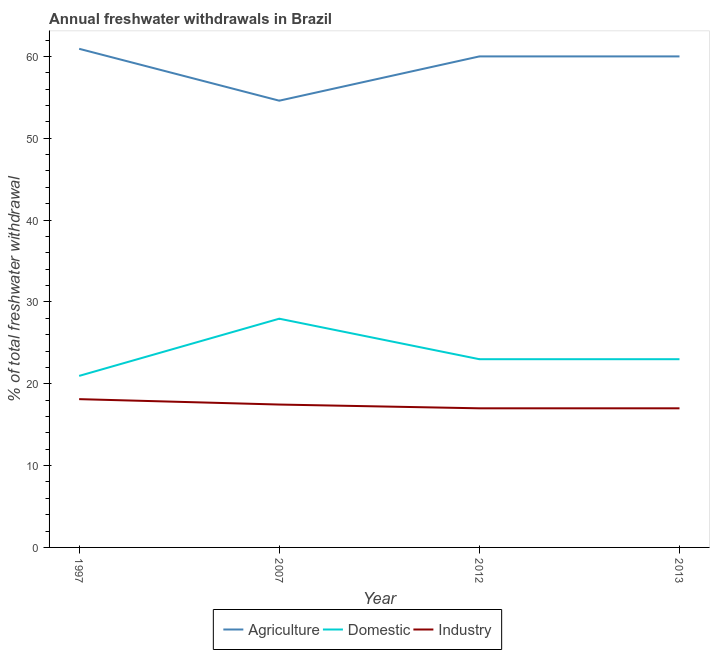Is the number of lines equal to the number of legend labels?
Ensure brevity in your answer.  Yes. What is the percentage of freshwater withdrawal for industry in 2012?
Make the answer very short. 17. Across all years, what is the maximum percentage of freshwater withdrawal for agriculture?
Offer a very short reply. 60.93. In which year was the percentage of freshwater withdrawal for agriculture minimum?
Keep it short and to the point. 2007. What is the total percentage of freshwater withdrawal for industry in the graph?
Offer a terse response. 69.58. What is the difference between the percentage of freshwater withdrawal for industry in 1997 and that in 2007?
Offer a very short reply. 0.66. What is the difference between the percentage of freshwater withdrawal for domestic purposes in 2013 and the percentage of freshwater withdrawal for agriculture in 2007?
Your answer should be very brief. -31.59. What is the average percentage of freshwater withdrawal for domestic purposes per year?
Provide a short and direct response. 23.73. In the year 2013, what is the difference between the percentage of freshwater withdrawal for domestic purposes and percentage of freshwater withdrawal for agriculture?
Offer a terse response. -37. In how many years, is the percentage of freshwater withdrawal for domestic purposes greater than 58 %?
Ensure brevity in your answer.  0. What is the ratio of the percentage of freshwater withdrawal for agriculture in 1997 to that in 2007?
Your answer should be compact. 1.12. What is the difference between the highest and the second highest percentage of freshwater withdrawal for agriculture?
Offer a terse response. 0.93. What is the difference between the highest and the lowest percentage of freshwater withdrawal for domestic purposes?
Your answer should be very brief. 6.99. In how many years, is the percentage of freshwater withdrawal for industry greater than the average percentage of freshwater withdrawal for industry taken over all years?
Your answer should be very brief. 2. Is it the case that in every year, the sum of the percentage of freshwater withdrawal for agriculture and percentage of freshwater withdrawal for domestic purposes is greater than the percentage of freshwater withdrawal for industry?
Your answer should be compact. Yes. Is the percentage of freshwater withdrawal for agriculture strictly greater than the percentage of freshwater withdrawal for industry over the years?
Give a very brief answer. Yes. Is the percentage of freshwater withdrawal for agriculture strictly less than the percentage of freshwater withdrawal for domestic purposes over the years?
Provide a succinct answer. No. How many lines are there?
Ensure brevity in your answer.  3. How many years are there in the graph?
Your response must be concise. 4. What is the difference between two consecutive major ticks on the Y-axis?
Keep it short and to the point. 10. Are the values on the major ticks of Y-axis written in scientific E-notation?
Your answer should be compact. No. How are the legend labels stacked?
Your answer should be very brief. Horizontal. What is the title of the graph?
Offer a terse response. Annual freshwater withdrawals in Brazil. What is the label or title of the X-axis?
Your answer should be compact. Year. What is the label or title of the Y-axis?
Your answer should be very brief. % of total freshwater withdrawal. What is the % of total freshwater withdrawal in Agriculture in 1997?
Give a very brief answer. 60.93. What is the % of total freshwater withdrawal of Domestic in 1997?
Provide a succinct answer. 20.96. What is the % of total freshwater withdrawal in Industry in 1997?
Your answer should be very brief. 18.12. What is the % of total freshwater withdrawal of Agriculture in 2007?
Give a very brief answer. 54.59. What is the % of total freshwater withdrawal in Domestic in 2007?
Offer a terse response. 27.95. What is the % of total freshwater withdrawal in Industry in 2007?
Keep it short and to the point. 17.46. What is the % of total freshwater withdrawal in Domestic in 2012?
Your answer should be compact. 23. What is the % of total freshwater withdrawal of Industry in 2012?
Provide a succinct answer. 17. What is the % of total freshwater withdrawal of Agriculture in 2013?
Provide a succinct answer. 60. What is the % of total freshwater withdrawal in Industry in 2013?
Offer a very short reply. 17. Across all years, what is the maximum % of total freshwater withdrawal of Agriculture?
Your answer should be very brief. 60.93. Across all years, what is the maximum % of total freshwater withdrawal in Domestic?
Offer a very short reply. 27.95. Across all years, what is the maximum % of total freshwater withdrawal of Industry?
Provide a succinct answer. 18.12. Across all years, what is the minimum % of total freshwater withdrawal in Agriculture?
Make the answer very short. 54.59. Across all years, what is the minimum % of total freshwater withdrawal in Domestic?
Keep it short and to the point. 20.96. What is the total % of total freshwater withdrawal of Agriculture in the graph?
Your answer should be very brief. 235.52. What is the total % of total freshwater withdrawal in Domestic in the graph?
Give a very brief answer. 94.91. What is the total % of total freshwater withdrawal of Industry in the graph?
Your response must be concise. 69.58. What is the difference between the % of total freshwater withdrawal of Agriculture in 1997 and that in 2007?
Provide a short and direct response. 6.34. What is the difference between the % of total freshwater withdrawal of Domestic in 1997 and that in 2007?
Offer a very short reply. -6.99. What is the difference between the % of total freshwater withdrawal of Industry in 1997 and that in 2007?
Offer a very short reply. 0.66. What is the difference between the % of total freshwater withdrawal of Agriculture in 1997 and that in 2012?
Make the answer very short. 0.93. What is the difference between the % of total freshwater withdrawal in Domestic in 1997 and that in 2012?
Ensure brevity in your answer.  -2.04. What is the difference between the % of total freshwater withdrawal of Industry in 1997 and that in 2012?
Offer a terse response. 1.12. What is the difference between the % of total freshwater withdrawal in Agriculture in 1997 and that in 2013?
Offer a terse response. 0.93. What is the difference between the % of total freshwater withdrawal of Domestic in 1997 and that in 2013?
Provide a succinct answer. -2.04. What is the difference between the % of total freshwater withdrawal in Industry in 1997 and that in 2013?
Ensure brevity in your answer.  1.12. What is the difference between the % of total freshwater withdrawal in Agriculture in 2007 and that in 2012?
Your response must be concise. -5.41. What is the difference between the % of total freshwater withdrawal of Domestic in 2007 and that in 2012?
Your answer should be very brief. 4.95. What is the difference between the % of total freshwater withdrawal of Industry in 2007 and that in 2012?
Provide a succinct answer. 0.46. What is the difference between the % of total freshwater withdrawal of Agriculture in 2007 and that in 2013?
Make the answer very short. -5.41. What is the difference between the % of total freshwater withdrawal of Domestic in 2007 and that in 2013?
Offer a terse response. 4.95. What is the difference between the % of total freshwater withdrawal in Industry in 2007 and that in 2013?
Give a very brief answer. 0.46. What is the difference between the % of total freshwater withdrawal of Domestic in 2012 and that in 2013?
Your answer should be very brief. 0. What is the difference between the % of total freshwater withdrawal in Agriculture in 1997 and the % of total freshwater withdrawal in Domestic in 2007?
Ensure brevity in your answer.  32.98. What is the difference between the % of total freshwater withdrawal in Agriculture in 1997 and the % of total freshwater withdrawal in Industry in 2007?
Offer a very short reply. 43.47. What is the difference between the % of total freshwater withdrawal of Domestic in 1997 and the % of total freshwater withdrawal of Industry in 2007?
Provide a succinct answer. 3.5. What is the difference between the % of total freshwater withdrawal of Agriculture in 1997 and the % of total freshwater withdrawal of Domestic in 2012?
Give a very brief answer. 37.93. What is the difference between the % of total freshwater withdrawal in Agriculture in 1997 and the % of total freshwater withdrawal in Industry in 2012?
Provide a short and direct response. 43.93. What is the difference between the % of total freshwater withdrawal in Domestic in 1997 and the % of total freshwater withdrawal in Industry in 2012?
Give a very brief answer. 3.96. What is the difference between the % of total freshwater withdrawal of Agriculture in 1997 and the % of total freshwater withdrawal of Domestic in 2013?
Make the answer very short. 37.93. What is the difference between the % of total freshwater withdrawal in Agriculture in 1997 and the % of total freshwater withdrawal in Industry in 2013?
Offer a very short reply. 43.93. What is the difference between the % of total freshwater withdrawal in Domestic in 1997 and the % of total freshwater withdrawal in Industry in 2013?
Provide a succinct answer. 3.96. What is the difference between the % of total freshwater withdrawal in Agriculture in 2007 and the % of total freshwater withdrawal in Domestic in 2012?
Make the answer very short. 31.59. What is the difference between the % of total freshwater withdrawal of Agriculture in 2007 and the % of total freshwater withdrawal of Industry in 2012?
Your answer should be compact. 37.59. What is the difference between the % of total freshwater withdrawal in Domestic in 2007 and the % of total freshwater withdrawal in Industry in 2012?
Ensure brevity in your answer.  10.95. What is the difference between the % of total freshwater withdrawal of Agriculture in 2007 and the % of total freshwater withdrawal of Domestic in 2013?
Your response must be concise. 31.59. What is the difference between the % of total freshwater withdrawal of Agriculture in 2007 and the % of total freshwater withdrawal of Industry in 2013?
Ensure brevity in your answer.  37.59. What is the difference between the % of total freshwater withdrawal in Domestic in 2007 and the % of total freshwater withdrawal in Industry in 2013?
Make the answer very short. 10.95. What is the average % of total freshwater withdrawal in Agriculture per year?
Provide a short and direct response. 58.88. What is the average % of total freshwater withdrawal in Domestic per year?
Your response must be concise. 23.73. What is the average % of total freshwater withdrawal in Industry per year?
Offer a terse response. 17.39. In the year 1997, what is the difference between the % of total freshwater withdrawal of Agriculture and % of total freshwater withdrawal of Domestic?
Keep it short and to the point. 39.97. In the year 1997, what is the difference between the % of total freshwater withdrawal of Agriculture and % of total freshwater withdrawal of Industry?
Provide a short and direct response. 42.81. In the year 1997, what is the difference between the % of total freshwater withdrawal in Domestic and % of total freshwater withdrawal in Industry?
Give a very brief answer. 2.84. In the year 2007, what is the difference between the % of total freshwater withdrawal in Agriculture and % of total freshwater withdrawal in Domestic?
Provide a succinct answer. 26.64. In the year 2007, what is the difference between the % of total freshwater withdrawal in Agriculture and % of total freshwater withdrawal in Industry?
Provide a succinct answer. 37.13. In the year 2007, what is the difference between the % of total freshwater withdrawal in Domestic and % of total freshwater withdrawal in Industry?
Give a very brief answer. 10.49. In the year 2012, what is the difference between the % of total freshwater withdrawal in Agriculture and % of total freshwater withdrawal in Domestic?
Offer a very short reply. 37. In the year 2012, what is the difference between the % of total freshwater withdrawal in Agriculture and % of total freshwater withdrawal in Industry?
Provide a short and direct response. 43. In the year 2013, what is the difference between the % of total freshwater withdrawal of Agriculture and % of total freshwater withdrawal of Industry?
Keep it short and to the point. 43. In the year 2013, what is the difference between the % of total freshwater withdrawal of Domestic and % of total freshwater withdrawal of Industry?
Provide a succinct answer. 6. What is the ratio of the % of total freshwater withdrawal of Agriculture in 1997 to that in 2007?
Your answer should be compact. 1.12. What is the ratio of the % of total freshwater withdrawal in Domestic in 1997 to that in 2007?
Offer a very short reply. 0.75. What is the ratio of the % of total freshwater withdrawal of Industry in 1997 to that in 2007?
Offer a very short reply. 1.04. What is the ratio of the % of total freshwater withdrawal of Agriculture in 1997 to that in 2012?
Your answer should be very brief. 1.02. What is the ratio of the % of total freshwater withdrawal of Domestic in 1997 to that in 2012?
Give a very brief answer. 0.91. What is the ratio of the % of total freshwater withdrawal in Industry in 1997 to that in 2012?
Ensure brevity in your answer.  1.07. What is the ratio of the % of total freshwater withdrawal in Agriculture in 1997 to that in 2013?
Keep it short and to the point. 1.02. What is the ratio of the % of total freshwater withdrawal of Domestic in 1997 to that in 2013?
Keep it short and to the point. 0.91. What is the ratio of the % of total freshwater withdrawal in Industry in 1997 to that in 2013?
Keep it short and to the point. 1.07. What is the ratio of the % of total freshwater withdrawal in Agriculture in 2007 to that in 2012?
Offer a very short reply. 0.91. What is the ratio of the % of total freshwater withdrawal in Domestic in 2007 to that in 2012?
Your answer should be compact. 1.22. What is the ratio of the % of total freshwater withdrawal of Industry in 2007 to that in 2012?
Your answer should be very brief. 1.03. What is the ratio of the % of total freshwater withdrawal in Agriculture in 2007 to that in 2013?
Provide a succinct answer. 0.91. What is the ratio of the % of total freshwater withdrawal of Domestic in 2007 to that in 2013?
Your response must be concise. 1.22. What is the ratio of the % of total freshwater withdrawal in Industry in 2007 to that in 2013?
Make the answer very short. 1.03. What is the ratio of the % of total freshwater withdrawal of Domestic in 2012 to that in 2013?
Your response must be concise. 1. What is the ratio of the % of total freshwater withdrawal of Industry in 2012 to that in 2013?
Give a very brief answer. 1. What is the difference between the highest and the second highest % of total freshwater withdrawal of Domestic?
Make the answer very short. 4.95. What is the difference between the highest and the second highest % of total freshwater withdrawal in Industry?
Your response must be concise. 0.66. What is the difference between the highest and the lowest % of total freshwater withdrawal in Agriculture?
Give a very brief answer. 6.34. What is the difference between the highest and the lowest % of total freshwater withdrawal of Domestic?
Keep it short and to the point. 6.99. What is the difference between the highest and the lowest % of total freshwater withdrawal in Industry?
Give a very brief answer. 1.12. 